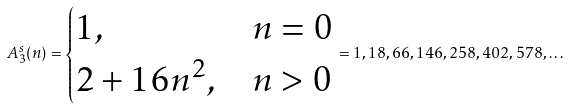<formula> <loc_0><loc_0><loc_500><loc_500>A _ { 3 } ^ { s } ( n ) = \begin{cases} 1 , & n = 0 \\ 2 + 1 6 n ^ { 2 } , & n > 0 \\ \end{cases} = 1 , 1 8 , 6 6 , 1 4 6 , 2 5 8 , 4 0 2 , 5 7 8 , \dots</formula> 